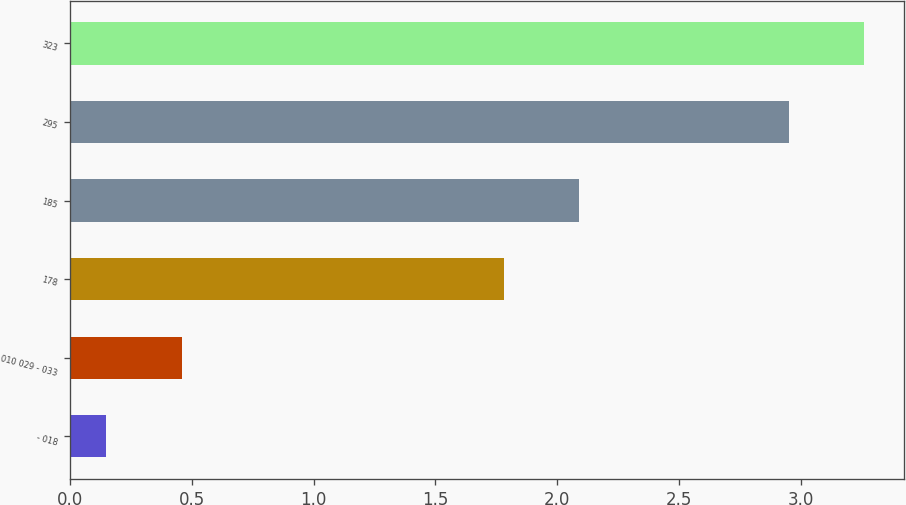Convert chart to OTSL. <chart><loc_0><loc_0><loc_500><loc_500><bar_chart><fcel>- 018<fcel>010 029 - 033<fcel>178<fcel>185<fcel>295<fcel>323<nl><fcel>0.15<fcel>0.46<fcel>1.78<fcel>2.09<fcel>2.95<fcel>3.26<nl></chart> 